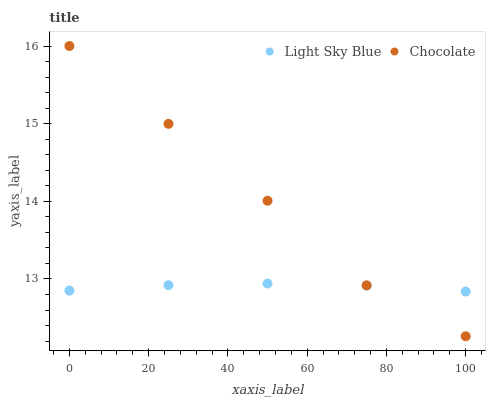Does Light Sky Blue have the minimum area under the curve?
Answer yes or no. Yes. Does Chocolate have the maximum area under the curve?
Answer yes or no. Yes. Does Chocolate have the minimum area under the curve?
Answer yes or no. No. Is Light Sky Blue the smoothest?
Answer yes or no. Yes. Is Chocolate the roughest?
Answer yes or no. Yes. Is Chocolate the smoothest?
Answer yes or no. No. Does Chocolate have the lowest value?
Answer yes or no. Yes. Does Chocolate have the highest value?
Answer yes or no. Yes. Does Chocolate intersect Light Sky Blue?
Answer yes or no. Yes. Is Chocolate less than Light Sky Blue?
Answer yes or no. No. Is Chocolate greater than Light Sky Blue?
Answer yes or no. No. 